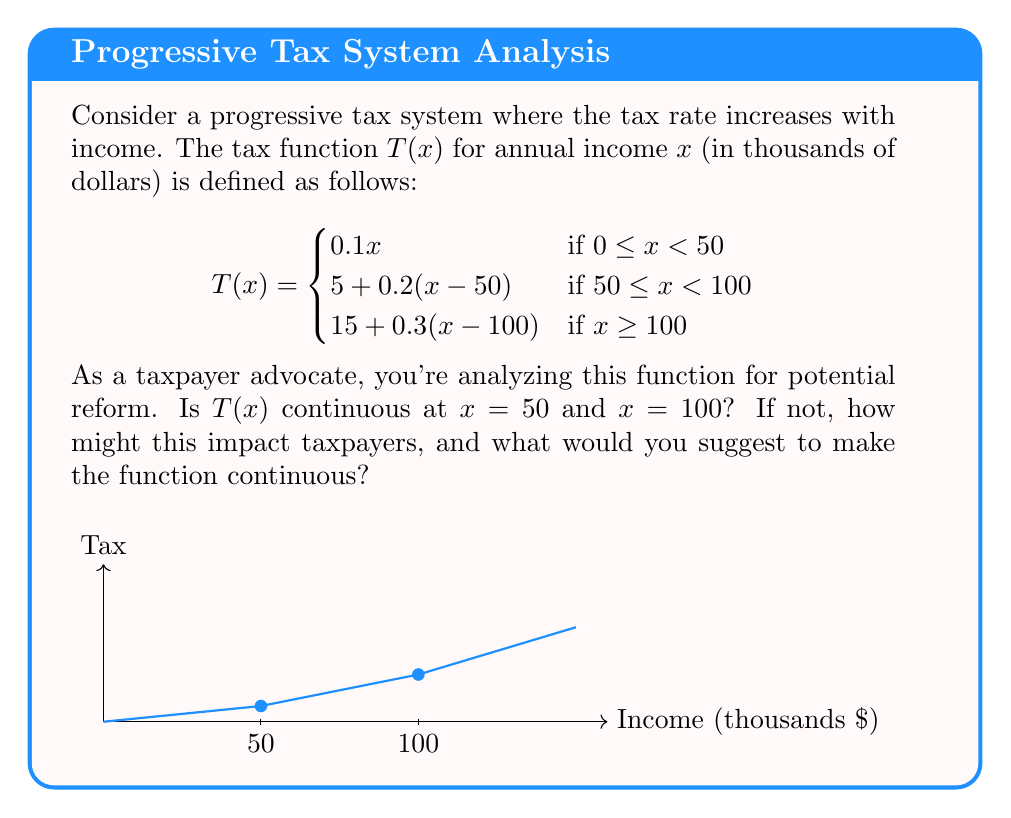Solve this math problem. To determine if $T(x)$ is continuous at $x = 50$ and $x = 100$, we need to check if the function satisfies the three conditions for continuity at these points:

1. The function is defined at the point.
2. The limit of the function as we approach the point from both sides exists.
3. The limit equals the function value at that point.

For $x = 50$:

1. $T(50)$ is defined: $T(50) = 5$
2. Left-hand limit: $\lim_{x \to 50^-} T(x) = \lim_{x \to 50^-} 0.1x = 5$
   Right-hand limit: $\lim_{x \to 50^+} T(x) = \lim_{x \to 50^+} [5 + 0.2(x-50)] = 5$
3. $\lim_{x \to 50} T(x) = T(50) = 5$

Therefore, $T(x)$ is continuous at $x = 50$.

For $x = 100$:

1. $T(100)$ is defined: $T(100) = 15$
2. Left-hand limit: $\lim_{x \to 100^-} T(x) = \lim_{x \to 100^-} [5 + 0.2(x-50)] = 15$
   Right-hand limit: $\lim_{x \to 100^+} T(x) = \lim_{x \to 100^+} [15 + 0.3(x-100)] = 15$
3. $\lim_{x \to 100} T(x) = T(100) = 15$

Therefore, $T(x)$ is continuous at $x = 100$.

The function $T(x)$ is continuous at both $x = 50$ and $x = 100$, which means there are no sudden jumps in tax liability as income crosses these thresholds. This is generally considered fair for taxpayers, as it avoids situations where a small increase in income could result in a disproportionately large increase in taxes.

However, while the function is continuous, it is not differentiable at these points due to the change in the rate of increase (slope). This creates "kinks" in the tax function, which could still be a point of concern for some taxpayers. To address this, you might suggest a more gradual increase in tax rates, perhaps using a smooth, continuously differentiable function instead of a piecewise linear one. This could be achieved using polynomial or exponential functions that approximate the current system but eliminate the sharp changes in marginal tax rates.
Answer: $T(x)$ is continuous at both $x = 50$ and $x = 100$. 